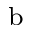<formula> <loc_0><loc_0><loc_500><loc_500>^ { b }</formula> 